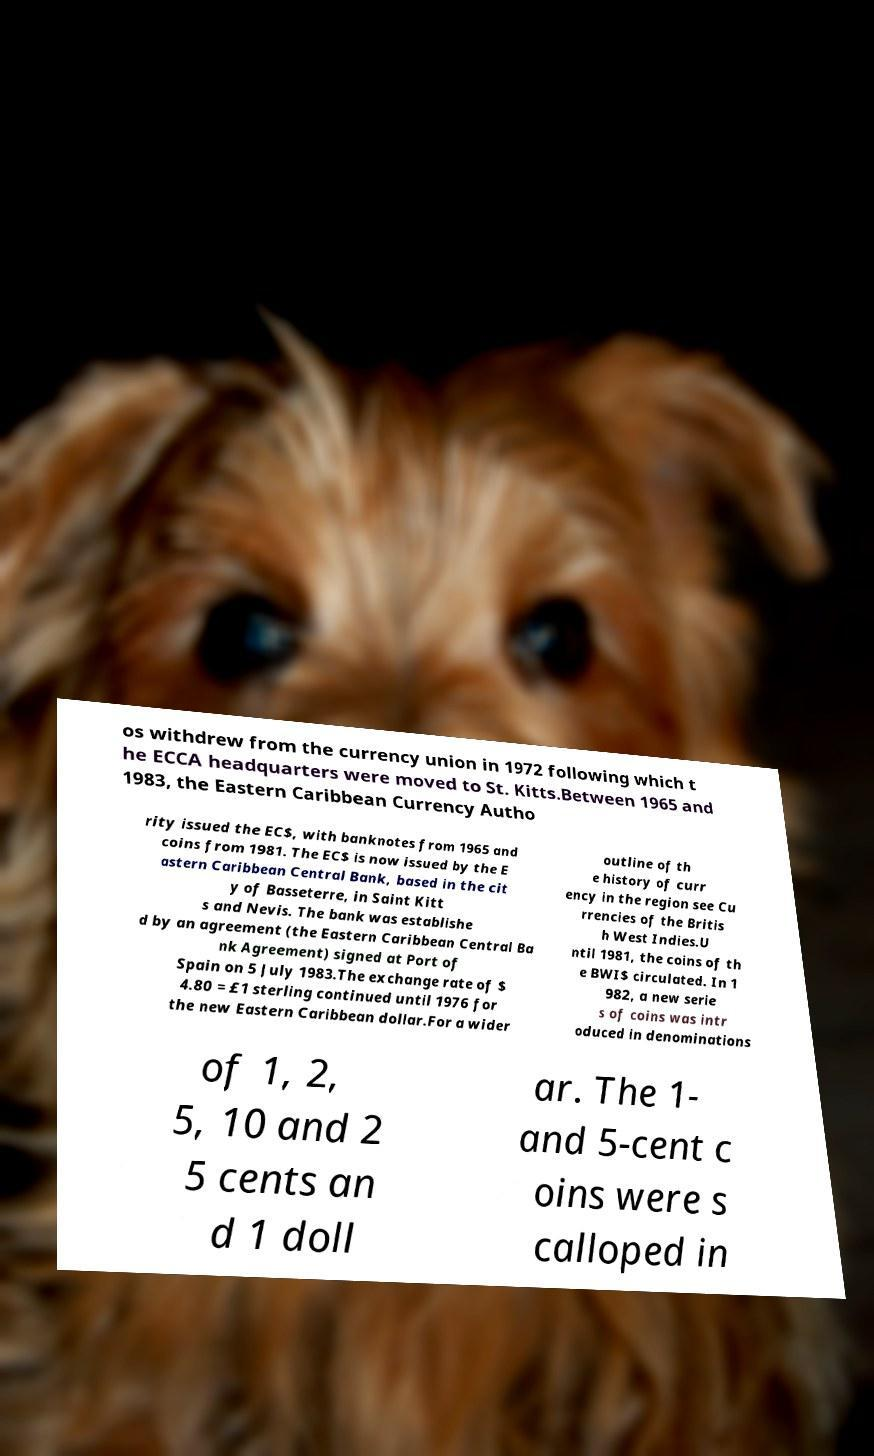Could you extract and type out the text from this image? os withdrew from the currency union in 1972 following which t he ECCA headquarters were moved to St. Kitts.Between 1965 and 1983, the Eastern Caribbean Currency Autho rity issued the EC$, with banknotes from 1965 and coins from 1981. The EC$ is now issued by the E astern Caribbean Central Bank, based in the cit y of Basseterre, in Saint Kitt s and Nevis. The bank was establishe d by an agreement (the Eastern Caribbean Central Ba nk Agreement) signed at Port of Spain on 5 July 1983.The exchange rate of $ 4.80 = £1 sterling continued until 1976 for the new Eastern Caribbean dollar.For a wider outline of th e history of curr ency in the region see Cu rrencies of the Britis h West Indies.U ntil 1981, the coins of th e BWI$ circulated. In 1 982, a new serie s of coins was intr oduced in denominations of 1, 2, 5, 10 and 2 5 cents an d 1 doll ar. The 1- and 5-cent c oins were s calloped in 